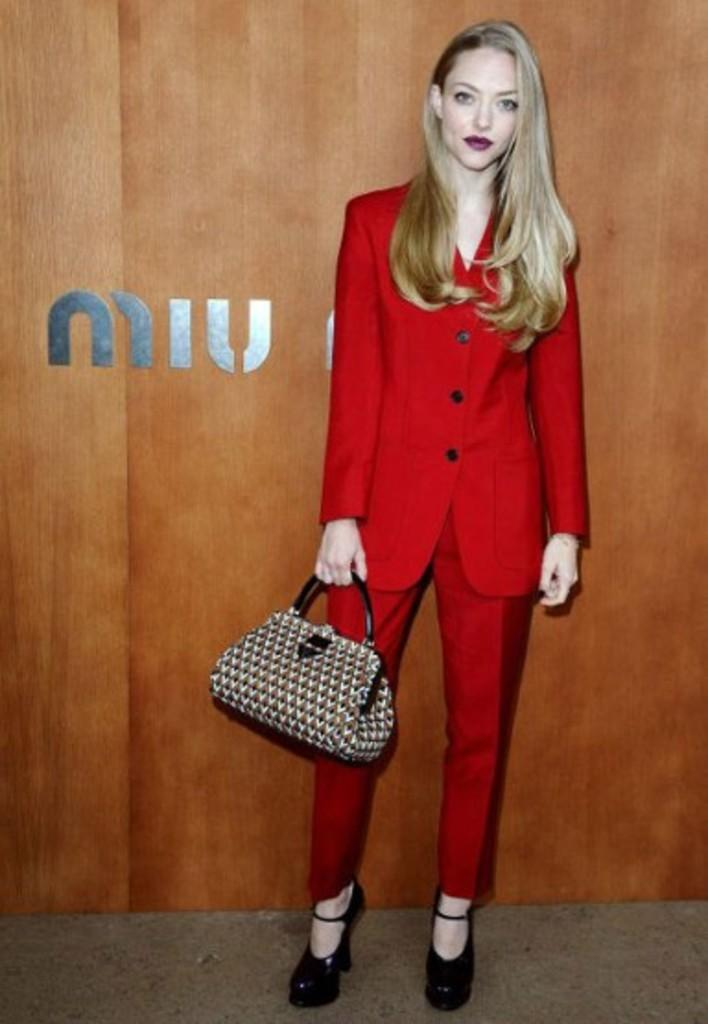Who is present in the image? There is a woman in the image. What is the woman wearing? The woman is wearing a red color blazer. What accessory is the woman holding? The woman is holding a leather handbag. What can be seen in the background of the image? There is a board in the image. How many beads are hanging from the lamp in the image? There is no lamp present in the image, so there are no beads to count. 